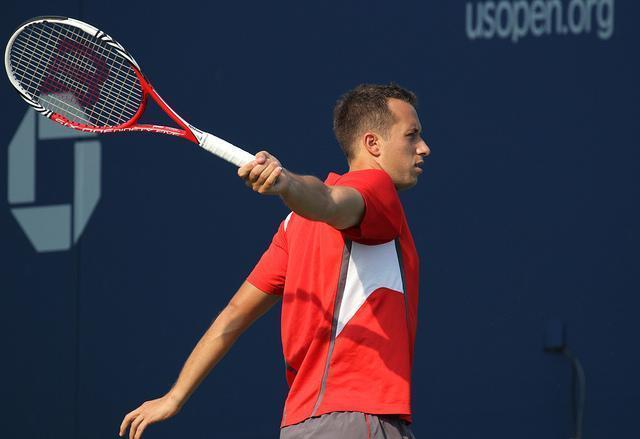How many people can be seen?
Give a very brief answer. 1. 